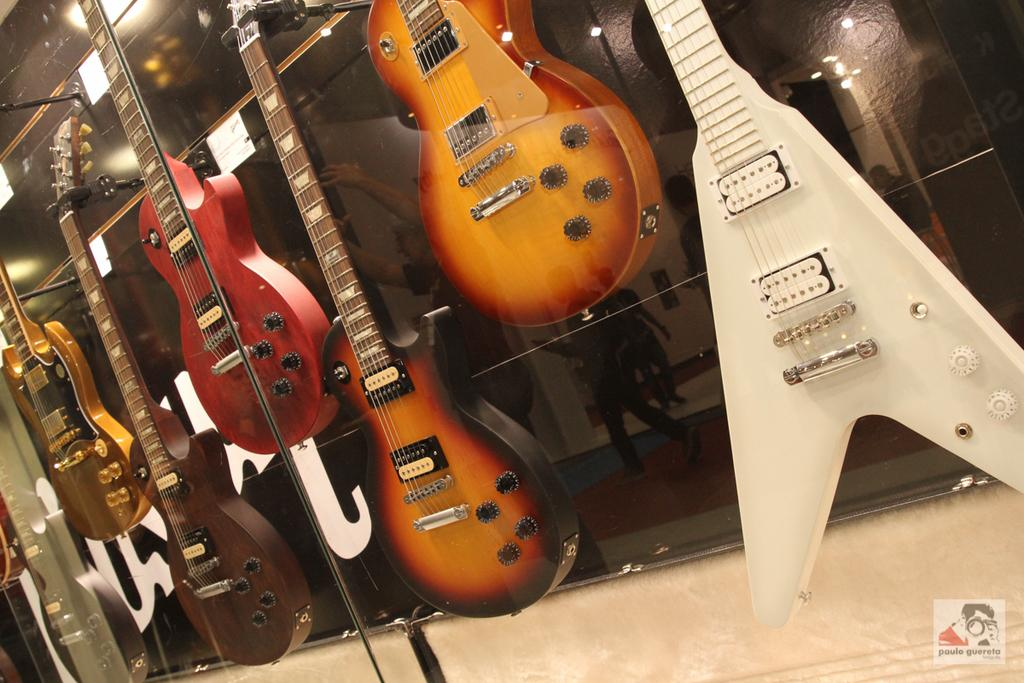What type of musical instruments are in the image? There are guitars in the image. Where are the guitars located? The guitars are hanging on the wall. What can be observed about the appearance of the guitars? The guitars are of different colors. What is the primary color of the background in the image? The background of the image is predominantly black. How many beads are hanging from the guitars in the image? There are no beads present in the image; it features guitars hanging on the wall. What type of crook can be seen interacting with the guitars in the image? There is no crook present in the image; only guitars are visible. 